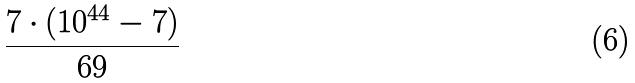Convert formula to latex. <formula><loc_0><loc_0><loc_500><loc_500>\frac { 7 \cdot ( 1 0 ^ { 4 4 } - 7 ) } { 6 9 }</formula> 